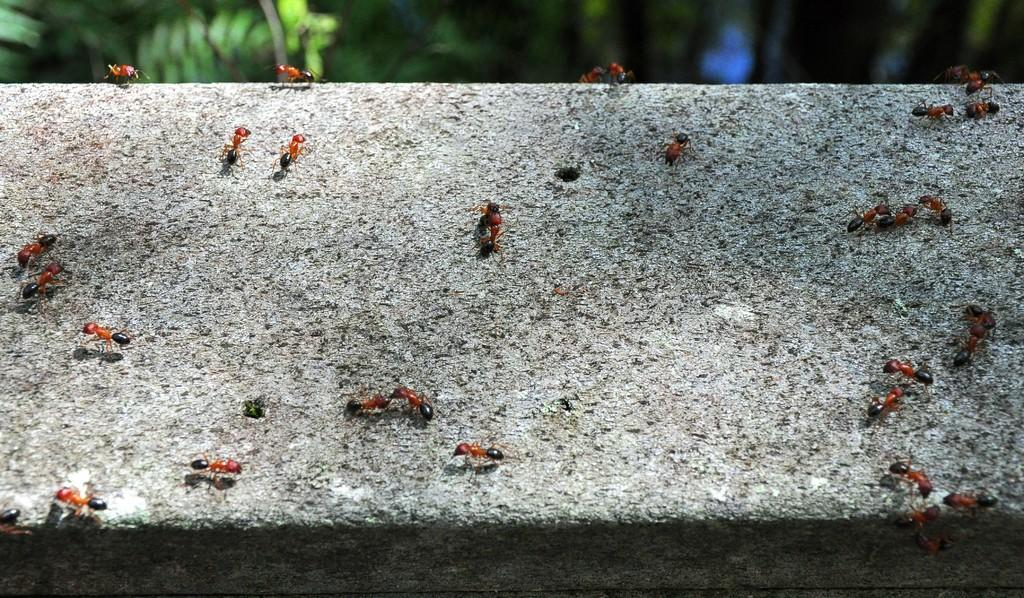What insects can be seen in the image? There are ants on a stone in the image. What type of vegetation is visible in the background of the image? There are trees visible in the background of the image. What type of quilt is being used to cover the ants in the image? There is no quilt present in the image; it features ants on a stone and trees in the background. 